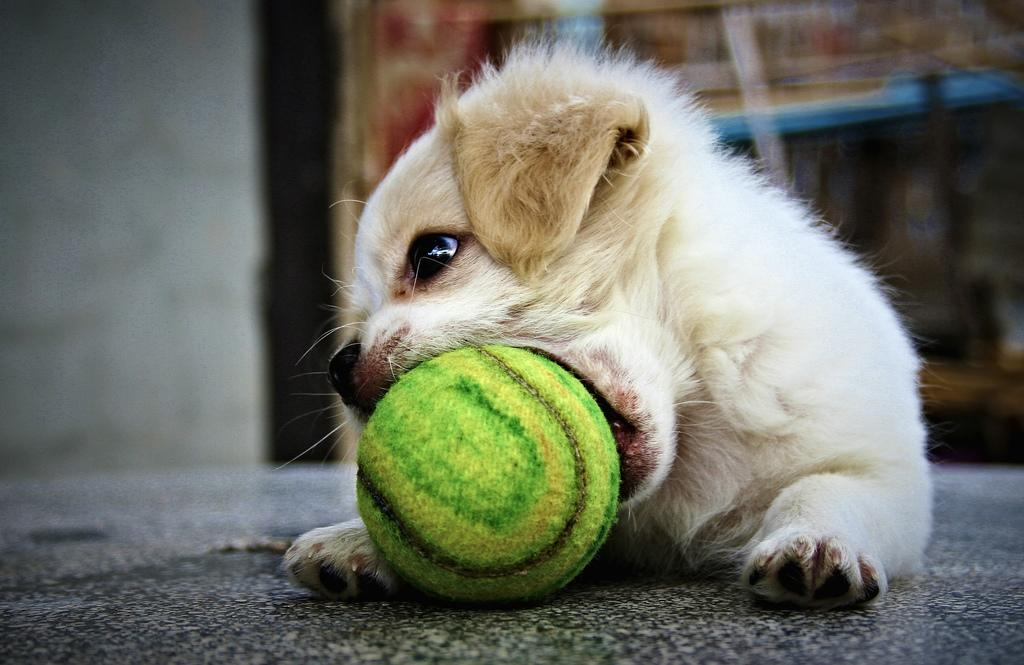What type of animal is in the image? There is a dog in the image. What object is on the floor in the image? There is a ball on the floor in the image. Can you describe the background of the image? The background of the image is blurry. How much wealth is visible in the image? There is no indication of wealth in the image; it features a dog and a ball on the floor with a blurry background. 